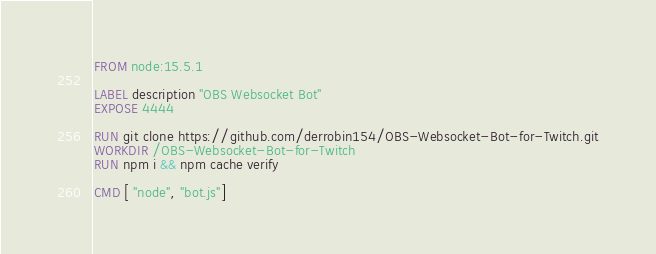Convert code to text. <code><loc_0><loc_0><loc_500><loc_500><_Dockerfile_>FROM node:15.5.1

LABEL description "OBS Websocket Bot"
EXPOSE 4444

RUN git clone https://github.com/derrobin154/OBS-Websocket-Bot-for-Twitch.git
WORKDIR /OBS-Websocket-Bot-for-Twitch
RUN npm i && npm cache verify

CMD [ "node", "bot.js"]</code> 